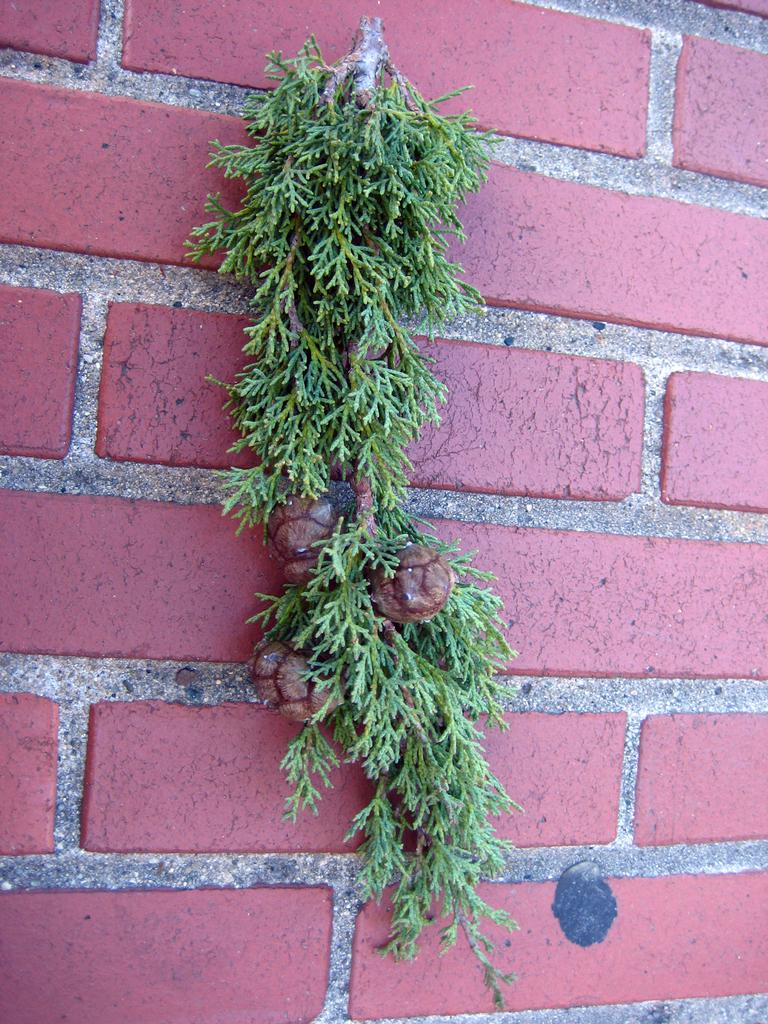What is present in the image? There is a plant in the image. Where is the plant located? The plant is on a brick wall. How many bookshelves are in the image? There is no mention of bookshelves or a library in the provided facts, so we cannot determine the number of bookshelves in the image. 